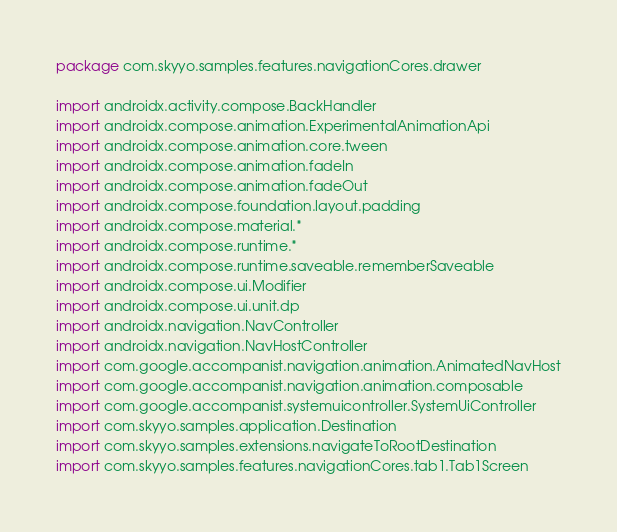Convert code to text. <code><loc_0><loc_0><loc_500><loc_500><_Kotlin_>package com.skyyo.samples.features.navigationCores.drawer

import androidx.activity.compose.BackHandler
import androidx.compose.animation.ExperimentalAnimationApi
import androidx.compose.animation.core.tween
import androidx.compose.animation.fadeIn
import androidx.compose.animation.fadeOut
import androidx.compose.foundation.layout.padding
import androidx.compose.material.*
import androidx.compose.runtime.*
import androidx.compose.runtime.saveable.rememberSaveable
import androidx.compose.ui.Modifier
import androidx.compose.ui.unit.dp
import androidx.navigation.NavController
import androidx.navigation.NavHostController
import com.google.accompanist.navigation.animation.AnimatedNavHost
import com.google.accompanist.navigation.animation.composable
import com.google.accompanist.systemuicontroller.SystemUiController
import com.skyyo.samples.application.Destination
import com.skyyo.samples.extensions.navigateToRootDestination
import com.skyyo.samples.features.navigationCores.tab1.Tab1Screen</code> 